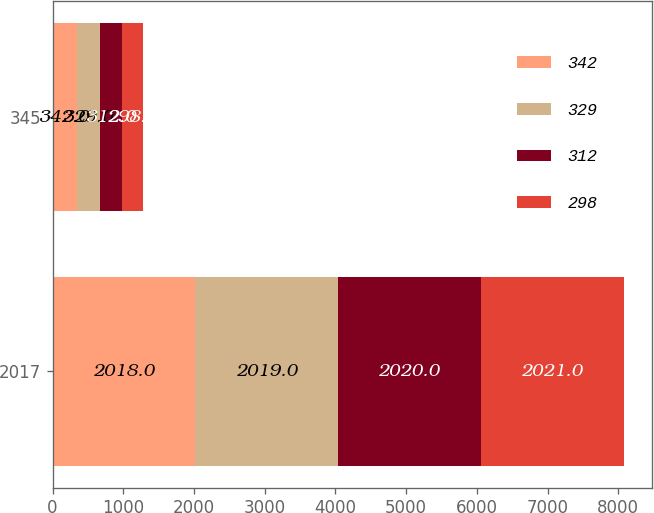Convert chart. <chart><loc_0><loc_0><loc_500><loc_500><stacked_bar_chart><ecel><fcel>2017<fcel>345<nl><fcel>342<fcel>2018<fcel>342<nl><fcel>329<fcel>2019<fcel>329<nl><fcel>312<fcel>2020<fcel>312<nl><fcel>298<fcel>2021<fcel>298<nl></chart> 